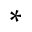Convert formula to latex. <formula><loc_0><loc_0><loc_500><loc_500>\ast</formula> 